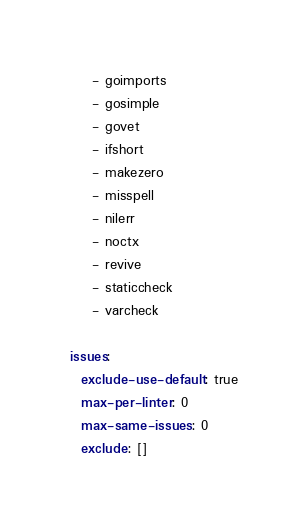Convert code to text. <code><loc_0><loc_0><loc_500><loc_500><_YAML_>    - goimports
    - gosimple
    - govet
    - ifshort
    - makezero
    - misspell
    - nilerr
    - noctx
    - revive
    - staticcheck
    - varcheck

issues:
  exclude-use-default: true
  max-per-linter: 0
  max-same-issues: 0
  exclude: []
</code> 